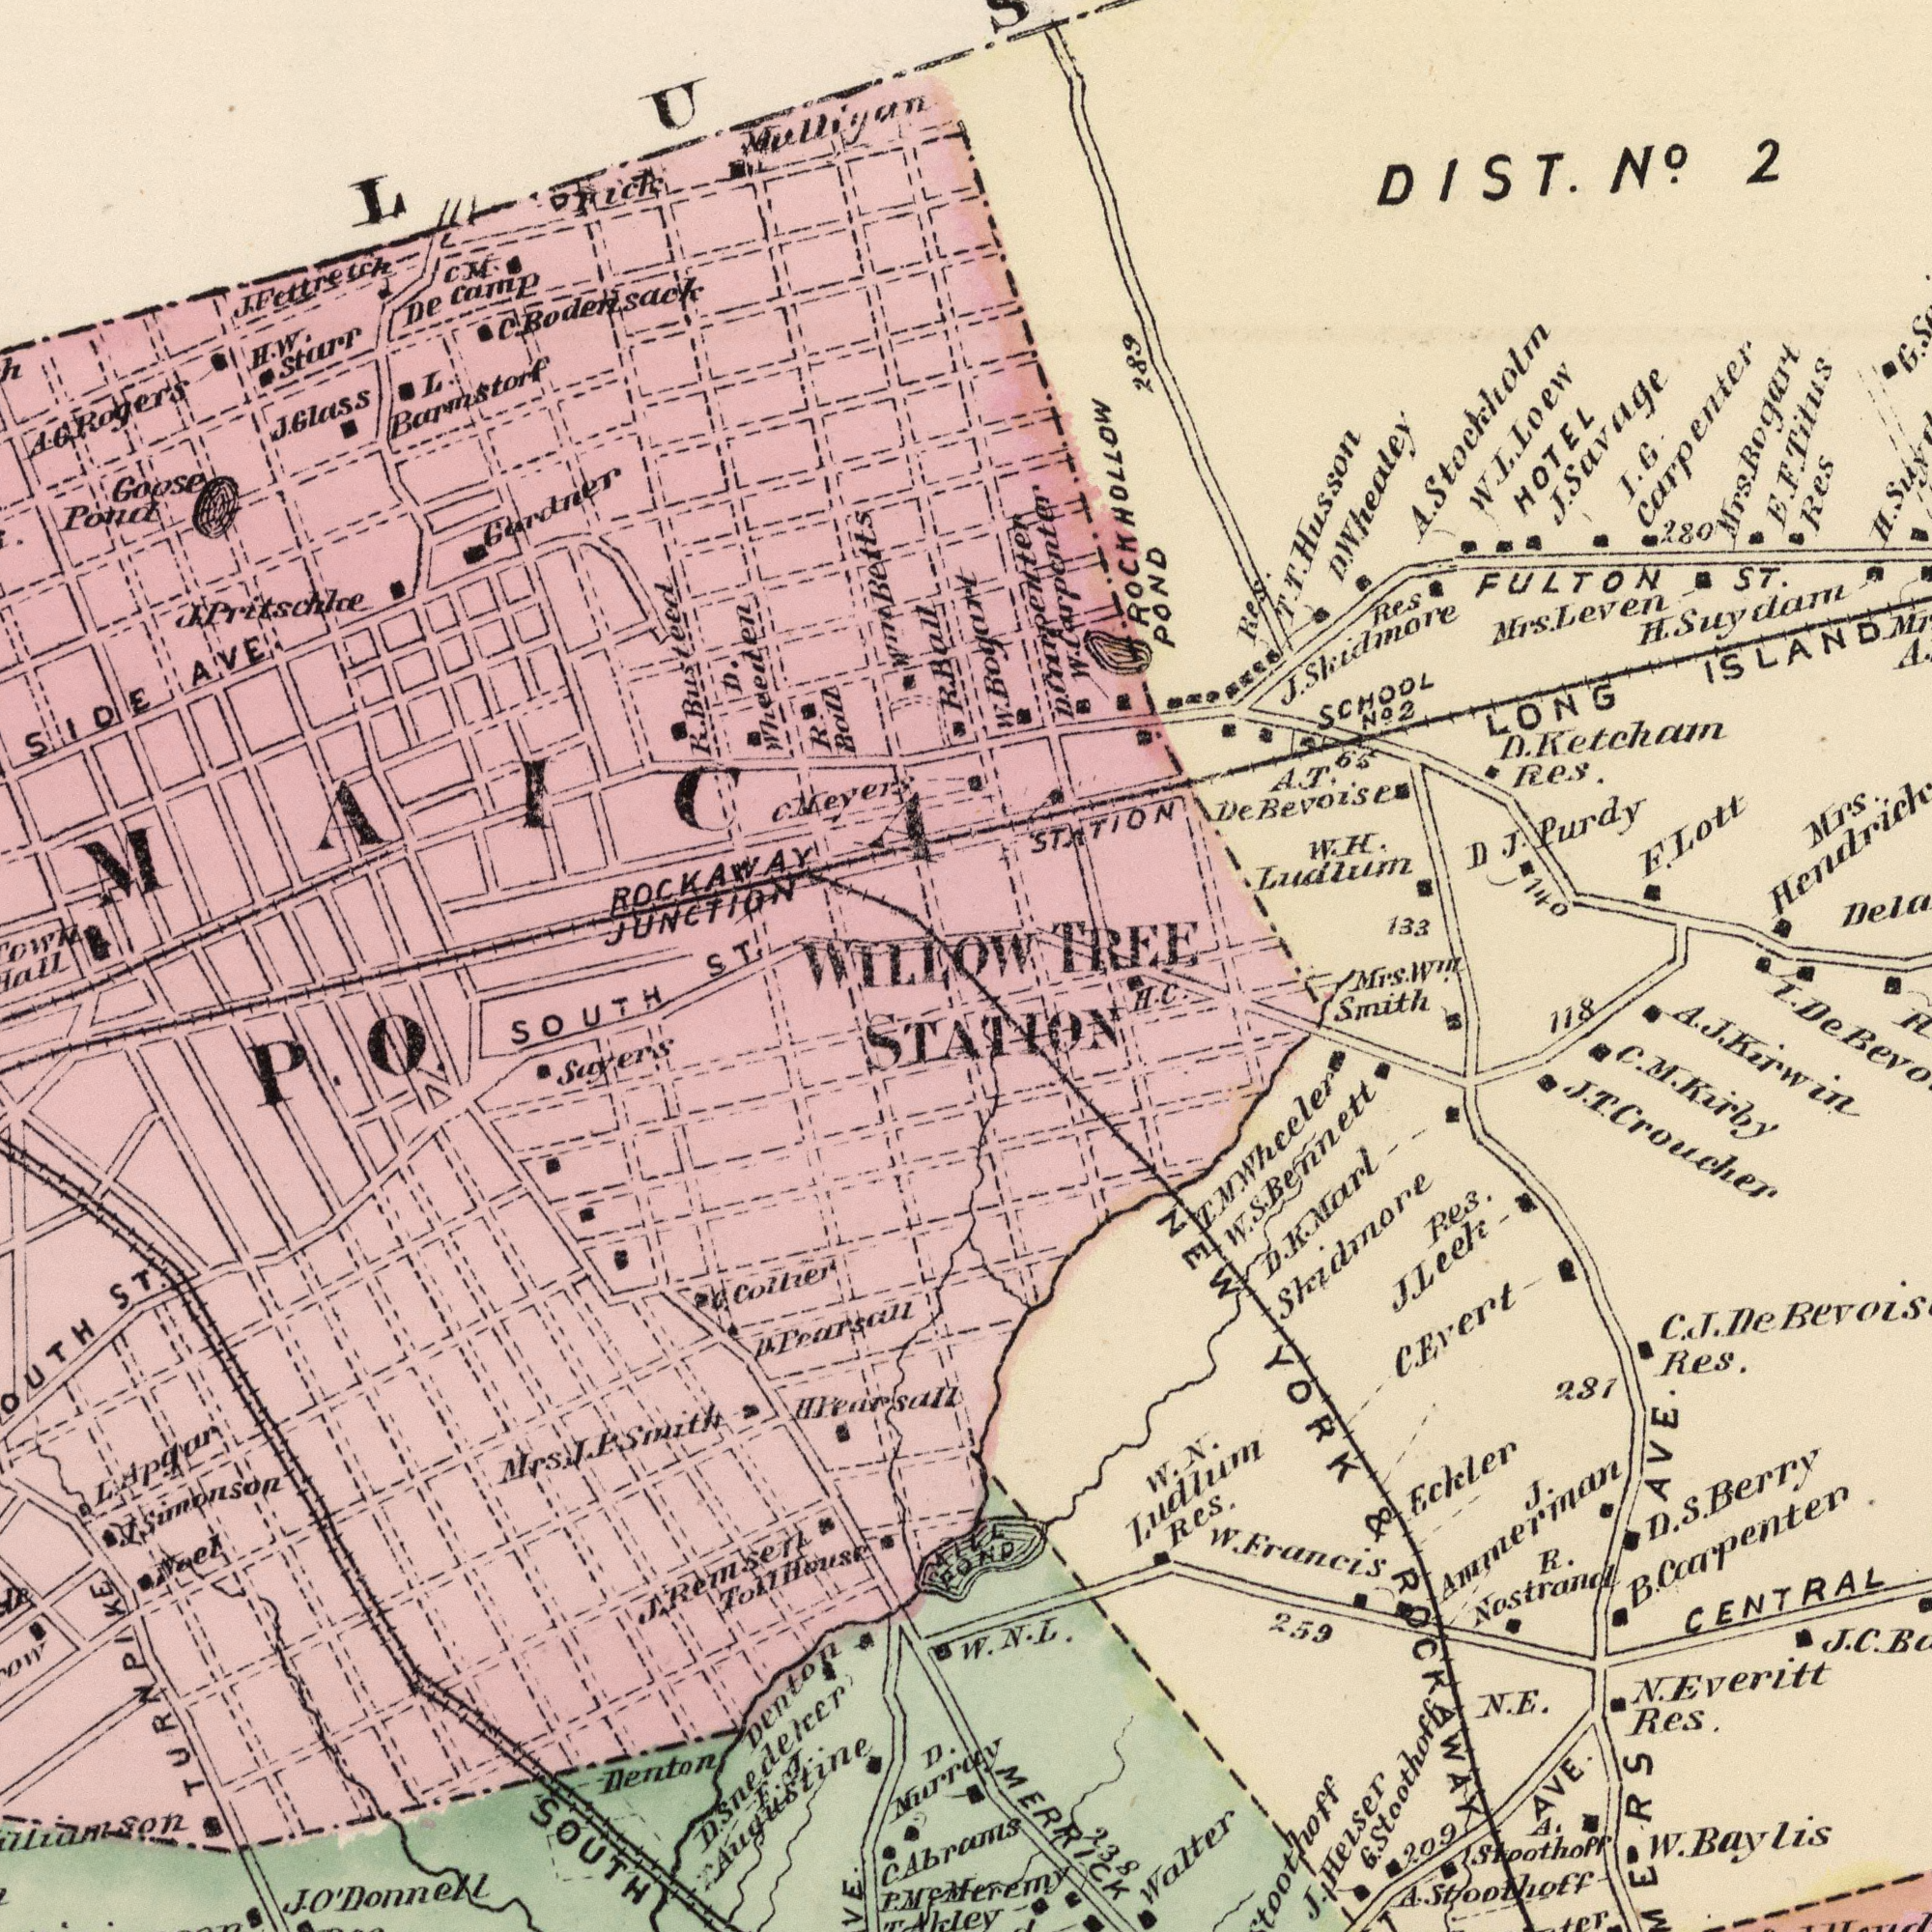What text is visible in the upper-right corner? DIST. No. 2 W. H. Ludlum Mrs. Hendrick STATION E. F. Titus D. J. Purdy Res I. G Carpenter H. Suydam FULTON ST. Res HOTEL SCHOOL No.2 Mrs. Leven F. Lott Res. D. Ketchatn Res. LONG ISLAND J. Skidmore Mrs. Bogart A. T. DeBevo J. Savage T. T. Husson W. L. Loew 140 A. Stockholm 289 280 133 G. 65 Mrs. Win. Smith H. C. I. TREE H. W. Bogart D. Carpcenter W. Carpcenter ROCKHOLLOW POND D. W. Whealey What text is shown in the bottom-right quadrant? MCMeremy CENTRAL C. Evert AVE. NEW YORK & ROCKAWAY C. J. Res. W. N. Ludlum Res. Skidmore Res. Eckler Walter J. Leek N.E. E. N. Everitt Res. A. Stoothoff D. S. Berry R. Nostrand T. M. Wheeler 281 J. J.Helser AVE. W. Baylis 118 A. Stoothoff 259 POND D. K. Marl 238 W. Francis B. Carpenter C. M. Kirby J. Ammeriaan W. N. L. De J.C.B C. 209 J. T. Croucher W. S. Bennett G. Stoothoff A. J. Kirwin MERRICK STATION What text can you see in the top-left section? SIDE AVE. J. J.Glass ROCKAWAY JUNCTION C. Neyers J. Pritschke Goose Pond R. Busteed A. G. Rogers C. M. De camp L. Barmstorf H. W. Sturr Gardner J. Fettretch L C. Bodersack R. Ball Pick D. Wheeden ST. Mulliyan WILLOW ###MAICA Wm Betts R. Ball What text is visible in the lower-left corner? SOUTH H. Pearsall Denton Sayers Mrs. J. P. Smith H. Pearsall ST. D. Murray C. Abrams SOUTH J. Sumonson Neel G. Collier P. O. J. O'Donnell T. Akley P. Denton L. Apgar F. T. T. Augustine J. Remsen Toll House TURNPIKE D. Snedeker Aill 